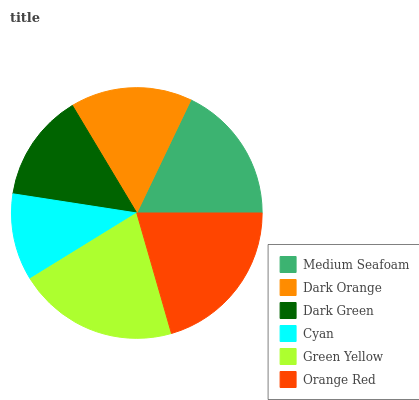Is Cyan the minimum?
Answer yes or no. Yes. Is Green Yellow the maximum?
Answer yes or no. Yes. Is Dark Orange the minimum?
Answer yes or no. No. Is Dark Orange the maximum?
Answer yes or no. No. Is Medium Seafoam greater than Dark Orange?
Answer yes or no. Yes. Is Dark Orange less than Medium Seafoam?
Answer yes or no. Yes. Is Dark Orange greater than Medium Seafoam?
Answer yes or no. No. Is Medium Seafoam less than Dark Orange?
Answer yes or no. No. Is Medium Seafoam the high median?
Answer yes or no. Yes. Is Dark Orange the low median?
Answer yes or no. Yes. Is Dark Green the high median?
Answer yes or no. No. Is Green Yellow the low median?
Answer yes or no. No. 